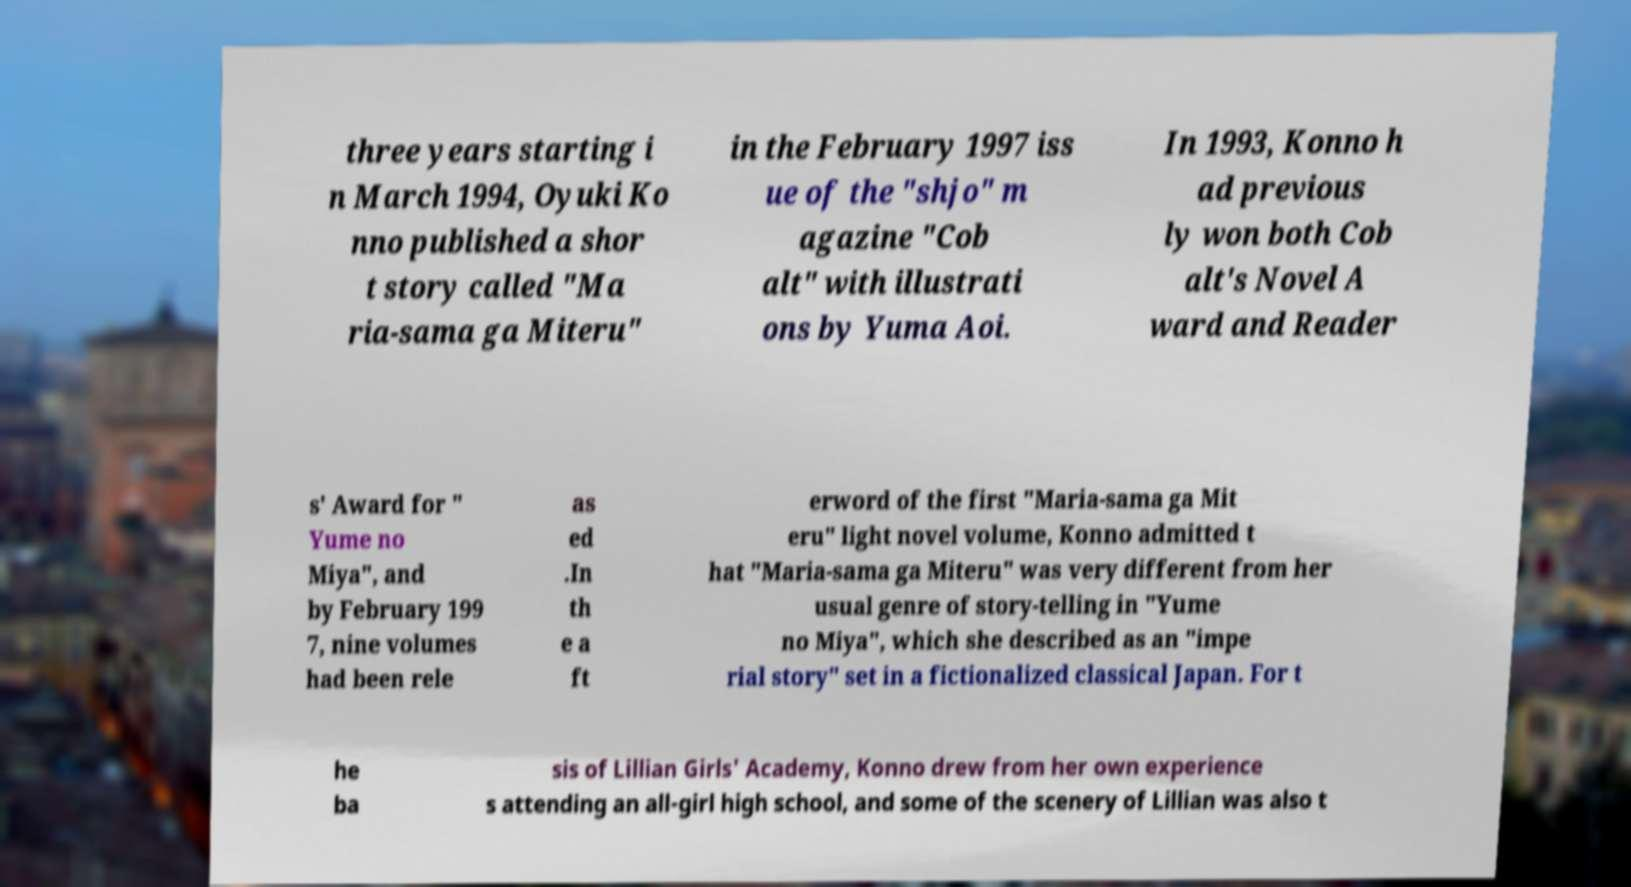For documentation purposes, I need the text within this image transcribed. Could you provide that? three years starting i n March 1994, Oyuki Ko nno published a shor t story called "Ma ria-sama ga Miteru" in the February 1997 iss ue of the "shjo" m agazine "Cob alt" with illustrati ons by Yuma Aoi. In 1993, Konno h ad previous ly won both Cob alt's Novel A ward and Reader s' Award for " Yume no Miya", and by February 199 7, nine volumes had been rele as ed .In th e a ft erword of the first "Maria-sama ga Mit eru" light novel volume, Konno admitted t hat "Maria-sama ga Miteru" was very different from her usual genre of story-telling in "Yume no Miya", which she described as an "impe rial story" set in a fictionalized classical Japan. For t he ba sis of Lillian Girls' Academy, Konno drew from her own experience s attending an all-girl high school, and some of the scenery of Lillian was also t 